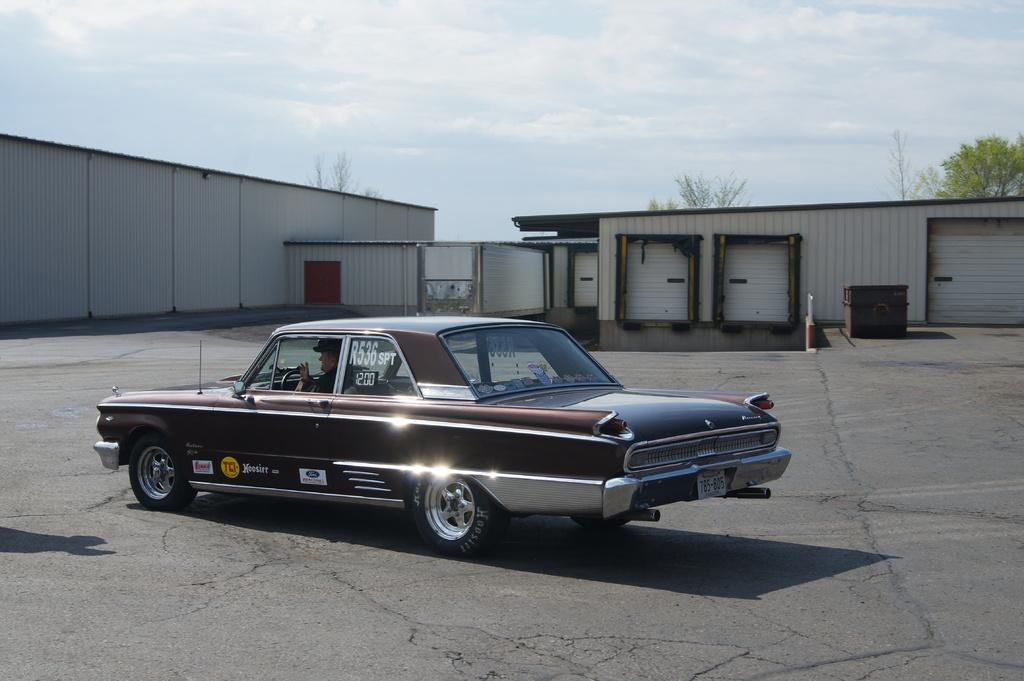What is the main subject of the image? There is a car on the road in the image. What can be seen in the background of the image? There are buildings in the background of the image, and trees are present behind the buildings. What is visible in the sky in the image? The sky is visible in the image, and clouds are present in the sky. How does the car wash itself in the image? The car does not wash itself in the image; it is simply a car on the road. 